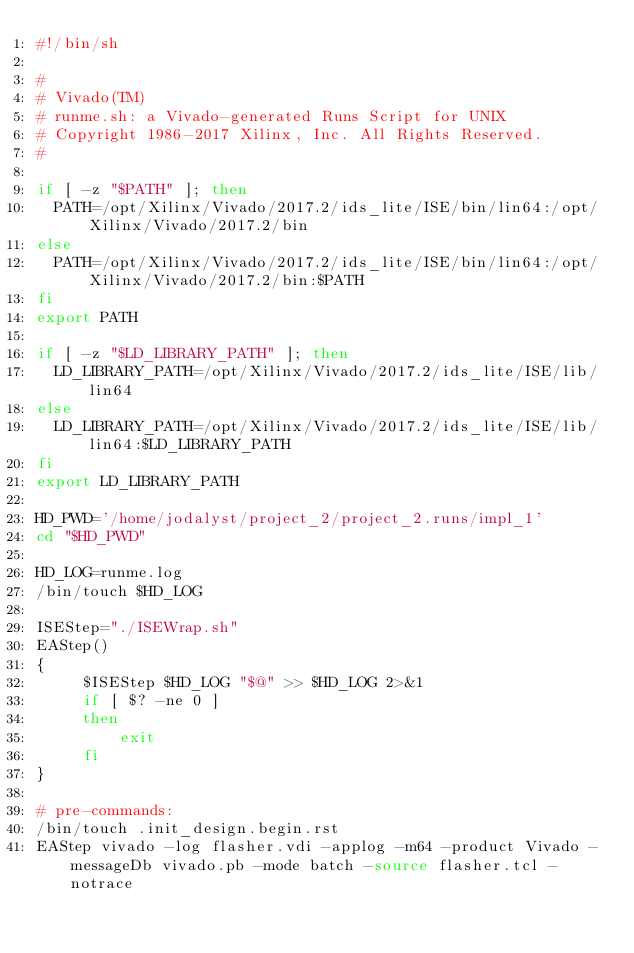Convert code to text. <code><loc_0><loc_0><loc_500><loc_500><_Bash_>#!/bin/sh

# 
# Vivado(TM)
# runme.sh: a Vivado-generated Runs Script for UNIX
# Copyright 1986-2017 Xilinx, Inc. All Rights Reserved.
# 

if [ -z "$PATH" ]; then
  PATH=/opt/Xilinx/Vivado/2017.2/ids_lite/ISE/bin/lin64:/opt/Xilinx/Vivado/2017.2/bin
else
  PATH=/opt/Xilinx/Vivado/2017.2/ids_lite/ISE/bin/lin64:/opt/Xilinx/Vivado/2017.2/bin:$PATH
fi
export PATH

if [ -z "$LD_LIBRARY_PATH" ]; then
  LD_LIBRARY_PATH=/opt/Xilinx/Vivado/2017.2/ids_lite/ISE/lib/lin64
else
  LD_LIBRARY_PATH=/opt/Xilinx/Vivado/2017.2/ids_lite/ISE/lib/lin64:$LD_LIBRARY_PATH
fi
export LD_LIBRARY_PATH

HD_PWD='/home/jodalyst/project_2/project_2.runs/impl_1'
cd "$HD_PWD"

HD_LOG=runme.log
/bin/touch $HD_LOG

ISEStep="./ISEWrap.sh"
EAStep()
{
     $ISEStep $HD_LOG "$@" >> $HD_LOG 2>&1
     if [ $? -ne 0 ]
     then
         exit
     fi
}

# pre-commands:
/bin/touch .init_design.begin.rst
EAStep vivado -log flasher.vdi -applog -m64 -product Vivado -messageDb vivado.pb -mode batch -source flasher.tcl -notrace


</code> 